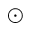Convert formula to latex. <formula><loc_0><loc_0><loc_500><loc_500>\odot</formula> 